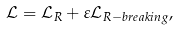Convert formula to latex. <formula><loc_0><loc_0><loc_500><loc_500>\mathcal { L } = \mathcal { L } _ { R } + \varepsilon \mathcal { L } _ { R - b r e a k i n g } ,</formula> 